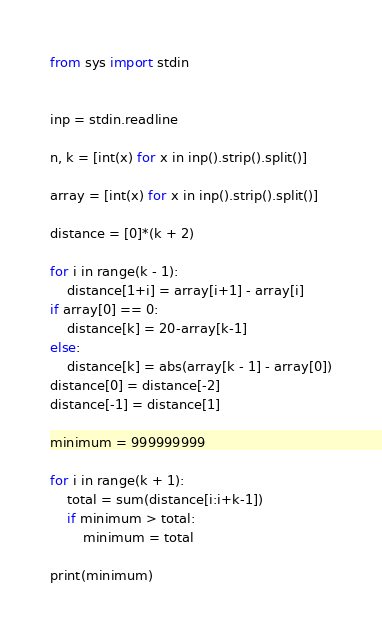Convert code to text. <code><loc_0><loc_0><loc_500><loc_500><_Python_>from sys import stdin


inp = stdin.readline

n, k = [int(x) for x in inp().strip().split()]

array = [int(x) for x in inp().strip().split()]

distance = [0]*(k + 2)

for i in range(k - 1):
    distance[1+i] = array[i+1] - array[i]
if array[0] == 0:
    distance[k] = 20-array[k-1]
else:
    distance[k] = abs(array[k - 1] - array[0])
distance[0] = distance[-2]
distance[-1] = distance[1]

minimum = 999999999

for i in range(k + 1):
    total = sum(distance[i:i+k-1])
    if minimum > total:
        minimum = total

print(minimum)
</code> 